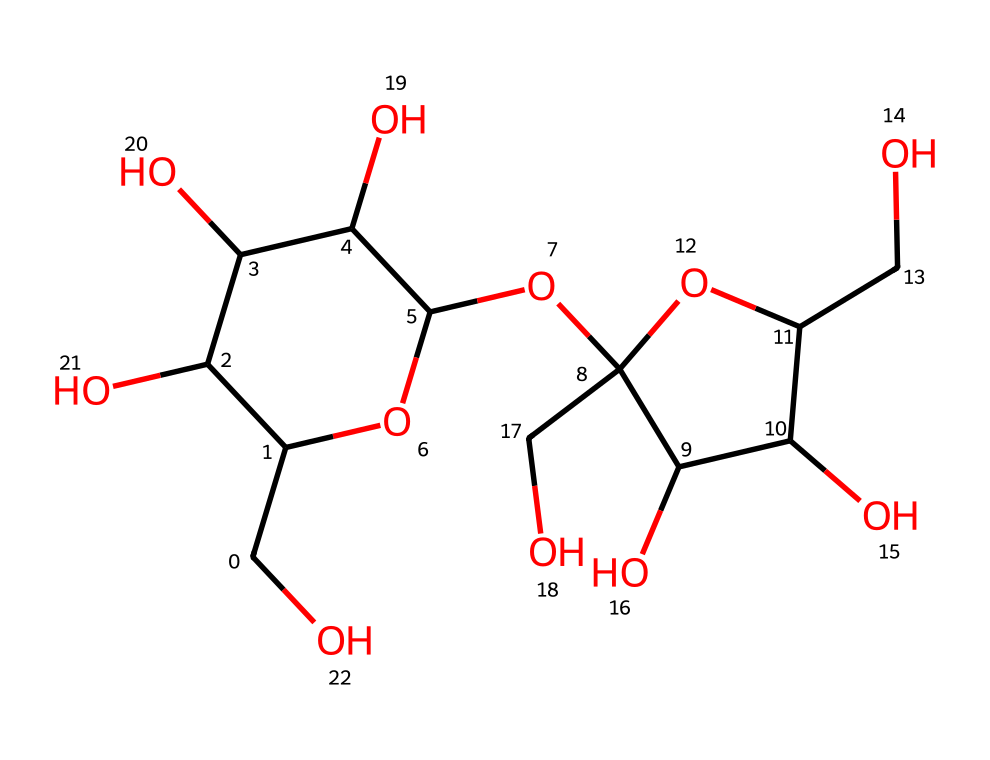What is the molecular formula of this compound? To find the molecular formula, we will count the number of each type of atom present in the SMILES. By analyzing the structure, we find there are 12 carbon atoms, 22 hydrogen atoms, and 11 oxygen atoms, which gives us the molecular formula C12H22O11.
Answer: C12H22O11 How many rings are present in the structure? By examining the SMILES representation, we observe two distinct cyclic structures indicated by the numbers 1 and 2 that show where the rings close. Thus, there are 2 rings in total.
Answer: 2 What type of carbohydrate is sucrose? Sucrose is classified as a disaccharide because it consists of two monosaccharide units joined together (glucose and fructose).
Answer: disaccharide How many hydroxyl (-OH) groups are present in this structure? By analyzing the structure, we can identify all the hydroxyl groups by counting each -OH functional group. There are 6 hydroxyl groups visible in the structure.
Answer: 6 What configuration does sucrose have at its anomeric carbon? The anomeric carbon of sucrose is formed from the glycosidic bond, which allows it to be in a glycosidic linkage with no free hydroxyl group. This indicates it has a non-reducing sugar configuration.
Answer: non-reducing Which part of the structure represents the glycosidic bond? The glycosidic bond can be identified where the two monosaccharides are linked through an oxygen atom, specifically between the hydroxyl group of one unit and the anomeric carbon of the other. This bond is crucial for forming sucrose from glucose and fructose.
Answer: oxygen atom 